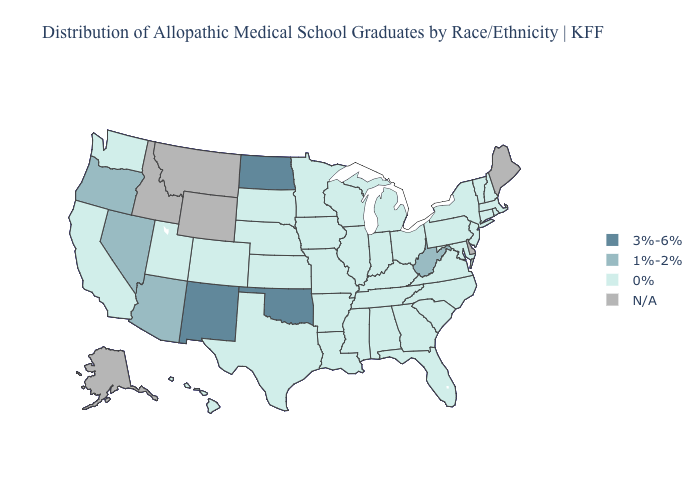What is the lowest value in the South?
Write a very short answer. 0%. Name the states that have a value in the range 0%?
Keep it brief. Alabama, Arkansas, California, Colorado, Connecticut, Florida, Georgia, Hawaii, Illinois, Indiana, Iowa, Kansas, Kentucky, Louisiana, Maryland, Massachusetts, Michigan, Minnesota, Mississippi, Missouri, Nebraska, New Hampshire, New Jersey, New York, North Carolina, Ohio, Pennsylvania, Rhode Island, South Carolina, South Dakota, Tennessee, Texas, Utah, Vermont, Virginia, Washington, Wisconsin. Does Texas have the highest value in the South?
Keep it brief. No. What is the highest value in the USA?
Answer briefly. 3%-6%. Which states have the lowest value in the USA?
Be succinct. Alabama, Arkansas, California, Colorado, Connecticut, Florida, Georgia, Hawaii, Illinois, Indiana, Iowa, Kansas, Kentucky, Louisiana, Maryland, Massachusetts, Michigan, Minnesota, Mississippi, Missouri, Nebraska, New Hampshire, New Jersey, New York, North Carolina, Ohio, Pennsylvania, Rhode Island, South Carolina, South Dakota, Tennessee, Texas, Utah, Vermont, Virginia, Washington, Wisconsin. Among the states that border Arkansas , which have the lowest value?
Give a very brief answer. Louisiana, Mississippi, Missouri, Tennessee, Texas. Among the states that border Alabama , which have the highest value?
Be succinct. Florida, Georgia, Mississippi, Tennessee. What is the value of North Dakota?
Short answer required. 3%-6%. What is the value of Nebraska?
Short answer required. 0%. Does Arkansas have the lowest value in the USA?
Give a very brief answer. Yes. How many symbols are there in the legend?
Keep it brief. 4. Name the states that have a value in the range N/A?
Quick response, please. Alaska, Delaware, Idaho, Maine, Montana, Wyoming. Name the states that have a value in the range 1%-2%?
Quick response, please. Arizona, Nevada, Oregon, West Virginia. What is the lowest value in states that border New Mexico?
Quick response, please. 0%. Among the states that border Nevada , which have the highest value?
Write a very short answer. Arizona, Oregon. 